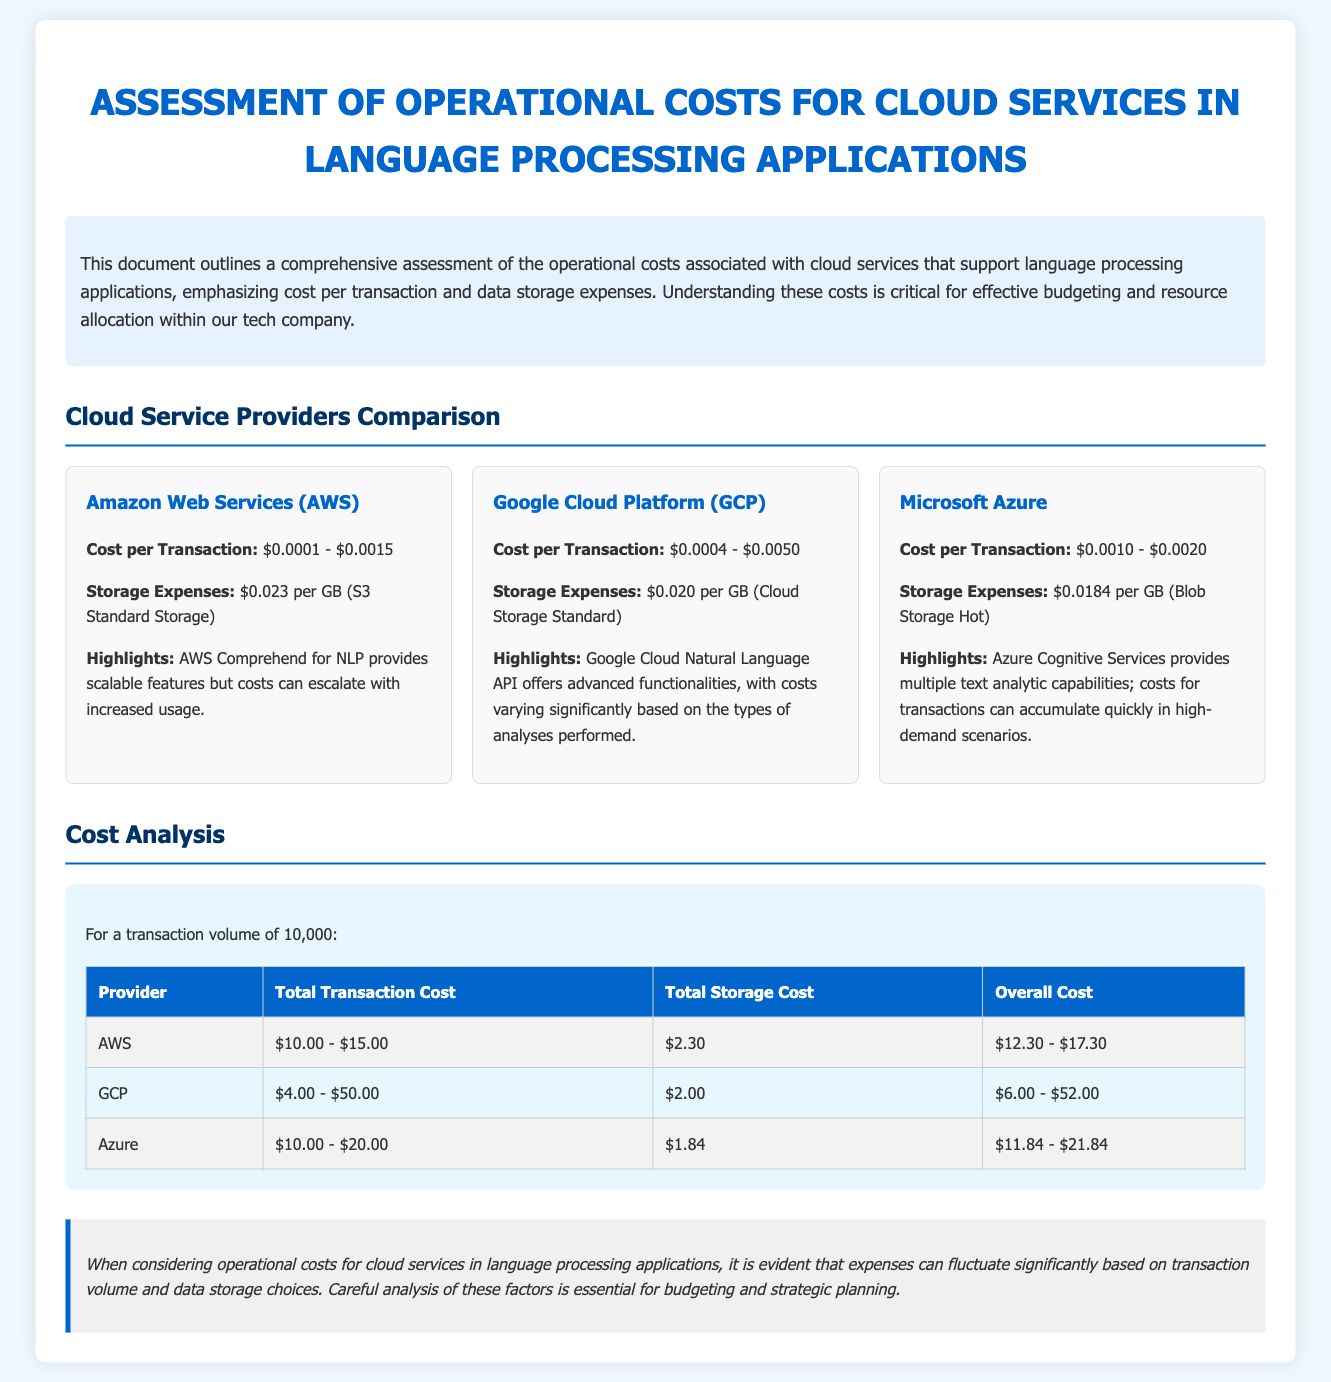What are the cost per transaction ranges for AWS? The document states that AWS's cost per transaction ranges from $0.0001 to $0.0015.
Answer: $0.0001 - $0.0015 What is the storage expense for GCP? According to the document, the storage expense for Google Cloud Platform is $0.020 per GB.
Answer: $0.020 per GB What is the total storage cost for Azure? The total storage cost for Azure is listed as $1.84 for the given transaction volume.
Answer: $1.84 How much can the total transaction cost for GCP range for 10,000 transactions? The document specifies that for 10,000 transactions, GCP transaction costs range from $4.00 to $50.00.
Answer: $4.00 - $50.00 Which cloud provider has the lowest storage expenses? The report indicates that Google Cloud Platform has the lowest storage expenses at $0.020 per GB.
Answer: Google Cloud Platform What is the overall cost range for AWS including storage expenses? The overall cost range for AWS, including storage expenses, is calculated as $12.30 to $17.30.
Answer: $12.30 - $17.30 What is the highlight feature of Azure? The highlight feature of Azure, as mentioned in the document, is its multiple text analytic capabilities.
Answer: Multiple text analytic capabilities What is the purpose of this financial report? The purpose of the report is to assess operational costs associated with cloud services supporting language processing applications.
Answer: Assess operational costs Which provider has the highest potential total cost for 10,000 transactions? The document shows that GCP has the highest potential total cost ranging up to $52.00, making it the highest.
Answer: GCP 